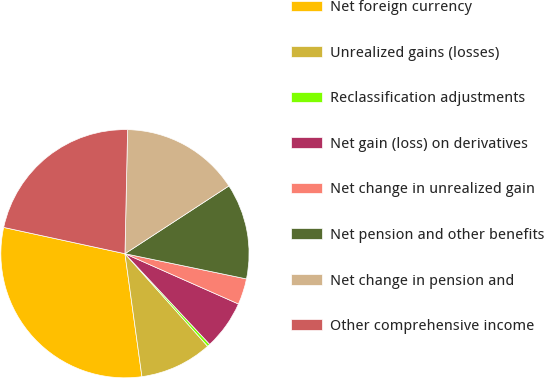Convert chart. <chart><loc_0><loc_0><loc_500><loc_500><pie_chart><fcel>Net foreign currency<fcel>Unrealized gains (losses)<fcel>Reclassification adjustments<fcel>Net gain (loss) on derivatives<fcel>Net change in unrealized gain<fcel>Net pension and other benefits<fcel>Net change in pension and<fcel>Other comprehensive income<nl><fcel>30.58%<fcel>9.42%<fcel>0.36%<fcel>6.4%<fcel>3.38%<fcel>12.45%<fcel>15.47%<fcel>21.94%<nl></chart> 